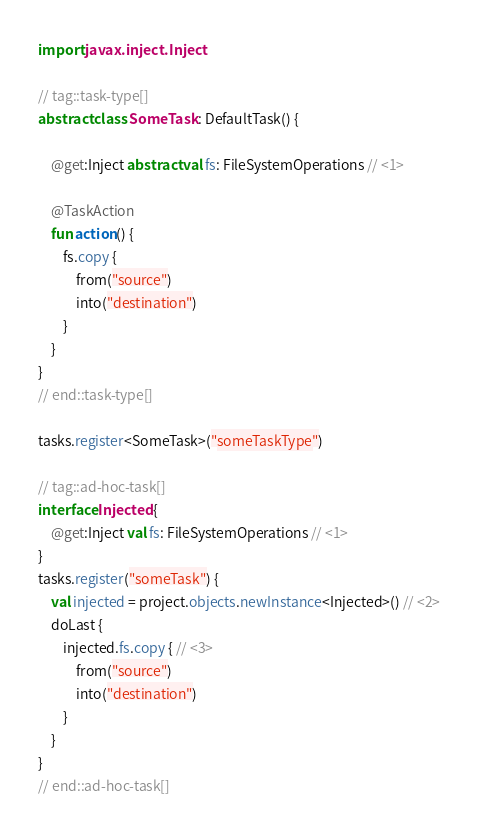Convert code to text. <code><loc_0><loc_0><loc_500><loc_500><_Kotlin_>import javax.inject.Inject

// tag::task-type[]
abstract class SomeTask : DefaultTask() {

    @get:Inject abstract val fs: FileSystemOperations // <1>

    @TaskAction
    fun action() {
        fs.copy {
            from("source")
            into("destination")
        }
    }
}
// end::task-type[]

tasks.register<SomeTask>("someTaskType")

// tag::ad-hoc-task[]
interface Injected {
    @get:Inject val fs: FileSystemOperations // <1>
}
tasks.register("someTask") {
    val injected = project.objects.newInstance<Injected>() // <2>
    doLast {
        injected.fs.copy { // <3>
            from("source")
            into("destination")
        }
    }
}
// end::ad-hoc-task[]
</code> 